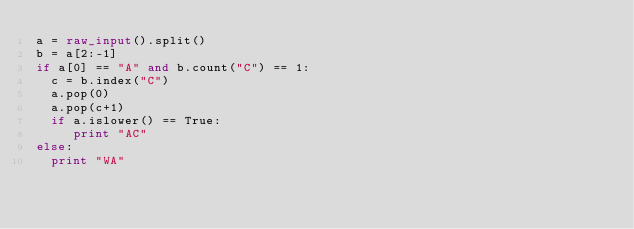Convert code to text. <code><loc_0><loc_0><loc_500><loc_500><_Python_>a = raw_input().split()
b = a[2:-1]
if a[0] == "A" and b.count("C") == 1:
  c = b.index("C")
  a.pop(0)
  a.pop(c+1)
  if a.islower() == True:
     print "AC"
else:
  print "WA"</code> 